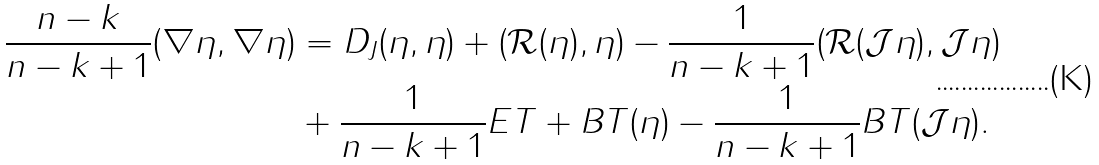Convert formula to latex. <formula><loc_0><loc_0><loc_500><loc_500>\frac { n - k } { n - k + 1 } ( \nabla \eta , \nabla \eta ) & = D _ { J } ( \eta , \eta ) + ( \mathcal { R } ( \eta ) , \eta ) - \frac { 1 } { n - k + 1 } ( \mathcal { R } ( \mathcal { J } \eta ) , \mathcal { J } \eta ) \\ & + \frac { 1 } { n - k + 1 } E T + B T ( \eta ) - \frac { 1 } { n - k + 1 } B T ( \mathcal { J } \eta ) .</formula> 